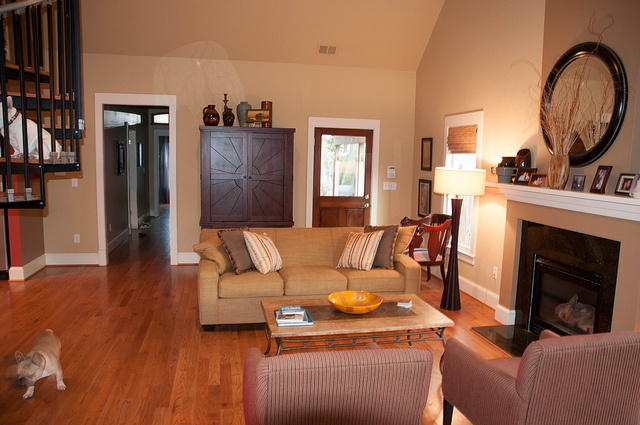Describe the objects in this image and their specific colors. I can see couch in black, salmon, brown, and tan tones, chair in black, brown, and maroon tones, couch in black, brown, and maroon tones, chair in black, brown, maroon, and tan tones, and dog in black, gray, tan, and brown tones in this image. 